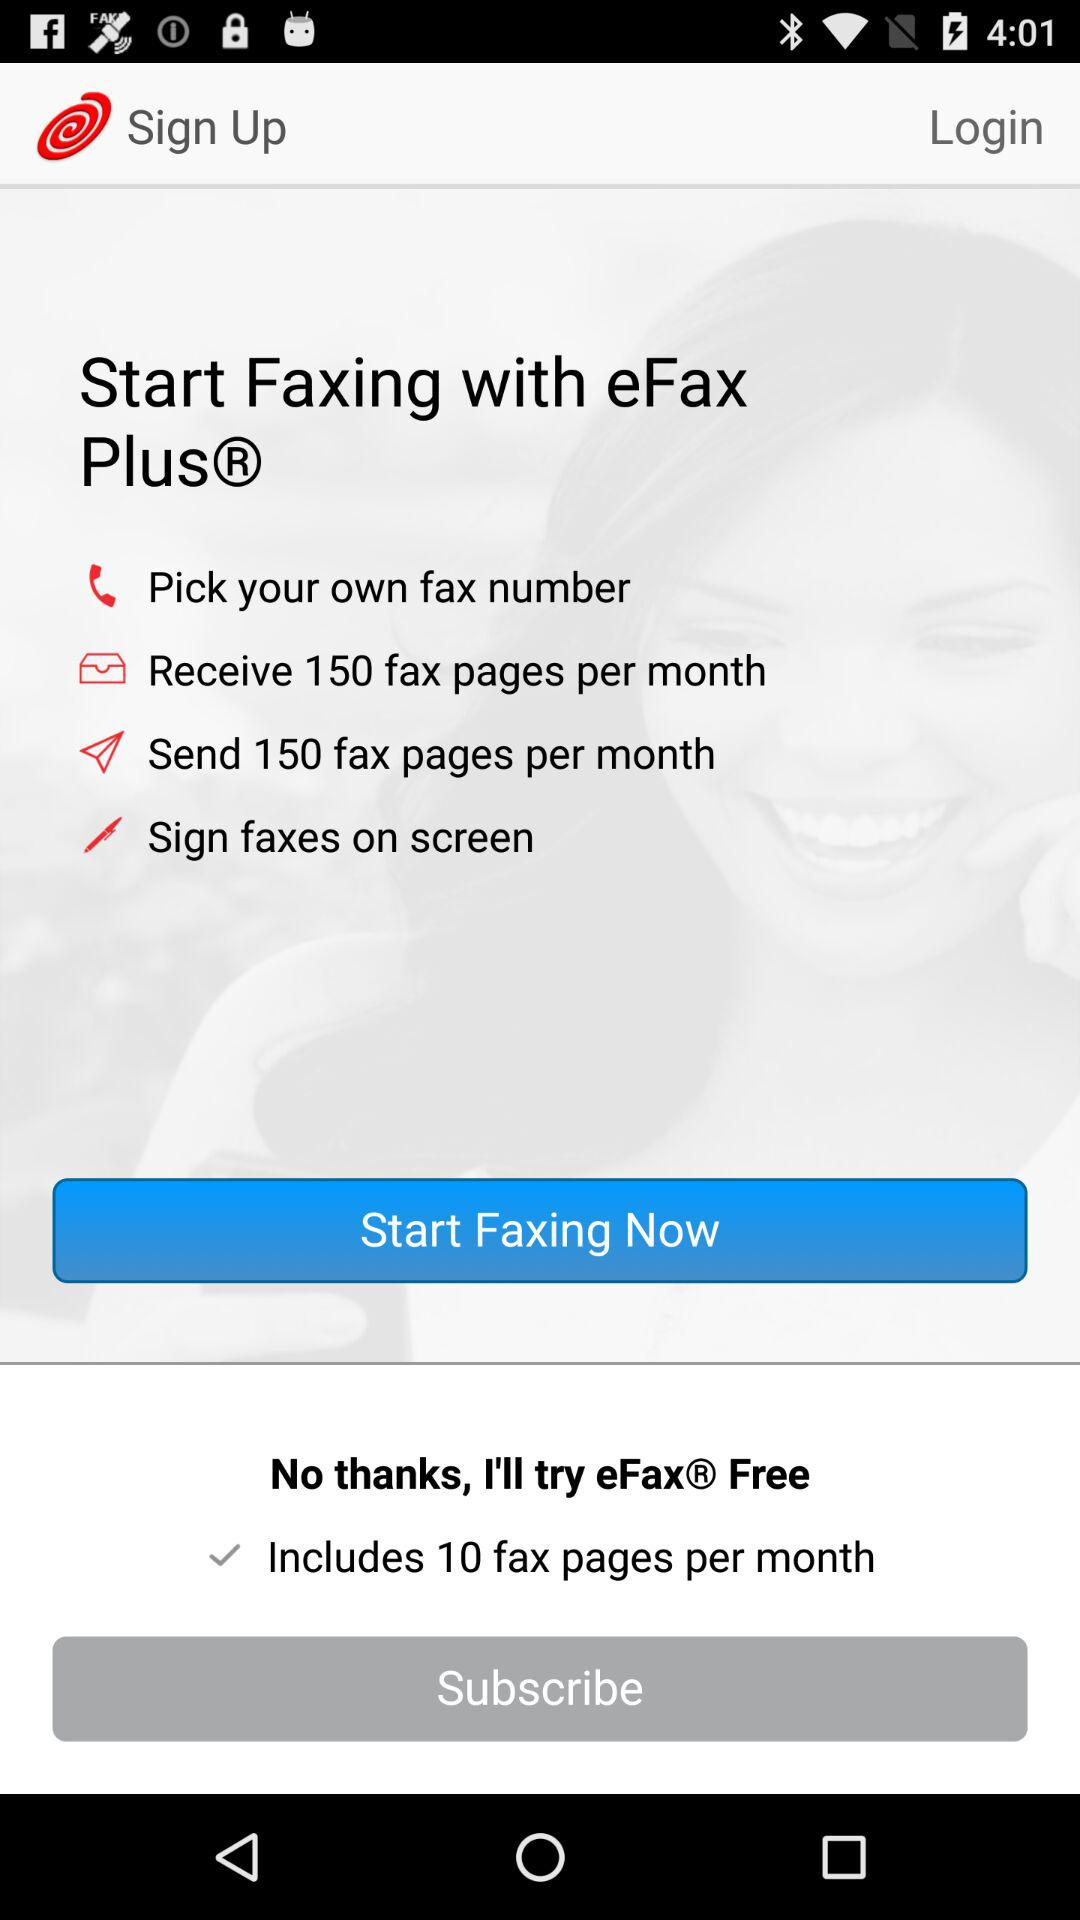How many fax pages can we receive per month? You can receive 150 fax pages per month. 